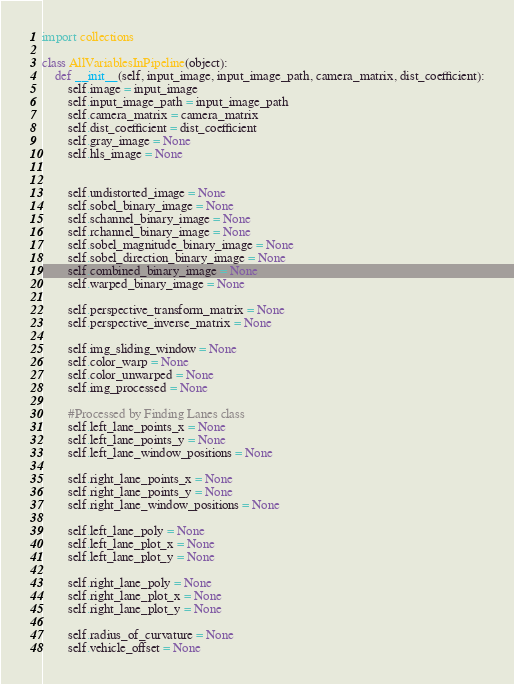<code> <loc_0><loc_0><loc_500><loc_500><_Python_>import collections

class AllVariablesInPipeline(object):
    def __init__(self, input_image, input_image_path, camera_matrix, dist_coefficient):
        self.image = input_image
        self.input_image_path = input_image_path
        self.camera_matrix = camera_matrix
        self.dist_coefficient = dist_coefficient
        self.gray_image = None
        self.hls_image = None

        
        self.undistorted_image = None
        self.sobel_binary_image = None
        self.schannel_binary_image = None
        self.rchannel_binary_image = None
        self.sobel_magnitude_binary_image = None
        self.sobel_direction_binary_image = None
        self.combined_binary_image = None
        self.warped_binary_image = None

        self.perspective_transform_matrix = None
        self.perspective_inverse_matrix = None

        self.img_sliding_window = None
        self.color_warp = None
        self.color_unwarped = None
        self.img_processed = None

        #Processed by Finding Lanes class
        self.left_lane_points_x = None
        self.left_lane_points_y = None
        self.left_lane_window_positions = None

        self.right_lane_points_x = None
        self.right_lane_points_y = None
        self.right_lane_window_positions = None

        self.left_lane_poly = None
        self.left_lane_plot_x = None
        self.left_lane_plot_y = None
        
        self.right_lane_poly = None
        self.right_lane_plot_x = None
        self.right_lane_plot_y = None

        self.radius_of_curvature = None
        self.vehicle_offset = None</code> 